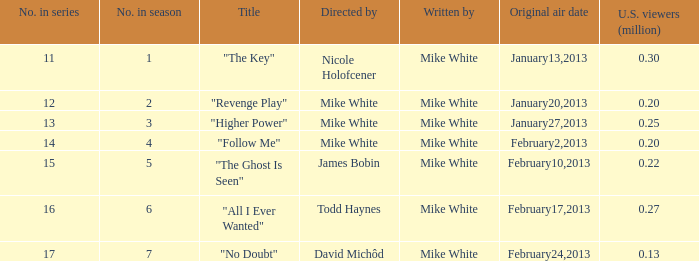What is the epithet of the episode orchestrated by james bobin? "The Ghost Is Seen". 